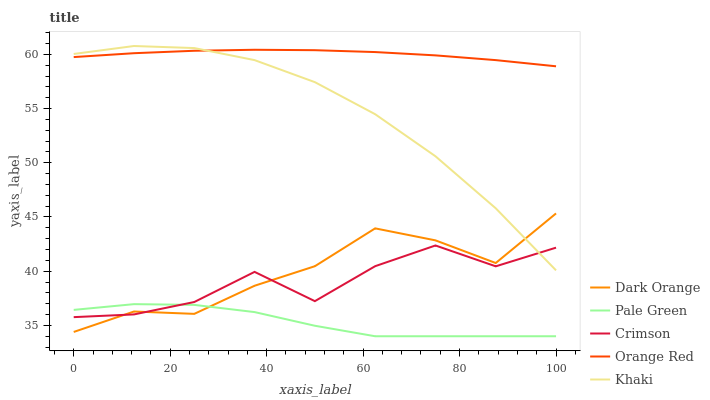Does Dark Orange have the minimum area under the curve?
Answer yes or no. No. Does Dark Orange have the maximum area under the curve?
Answer yes or no. No. Is Dark Orange the smoothest?
Answer yes or no. No. Is Dark Orange the roughest?
Answer yes or no. No. Does Dark Orange have the lowest value?
Answer yes or no. No. Does Dark Orange have the highest value?
Answer yes or no. No. Is Crimson less than Orange Red?
Answer yes or no. Yes. Is Orange Red greater than Pale Green?
Answer yes or no. Yes. Does Crimson intersect Orange Red?
Answer yes or no. No. 